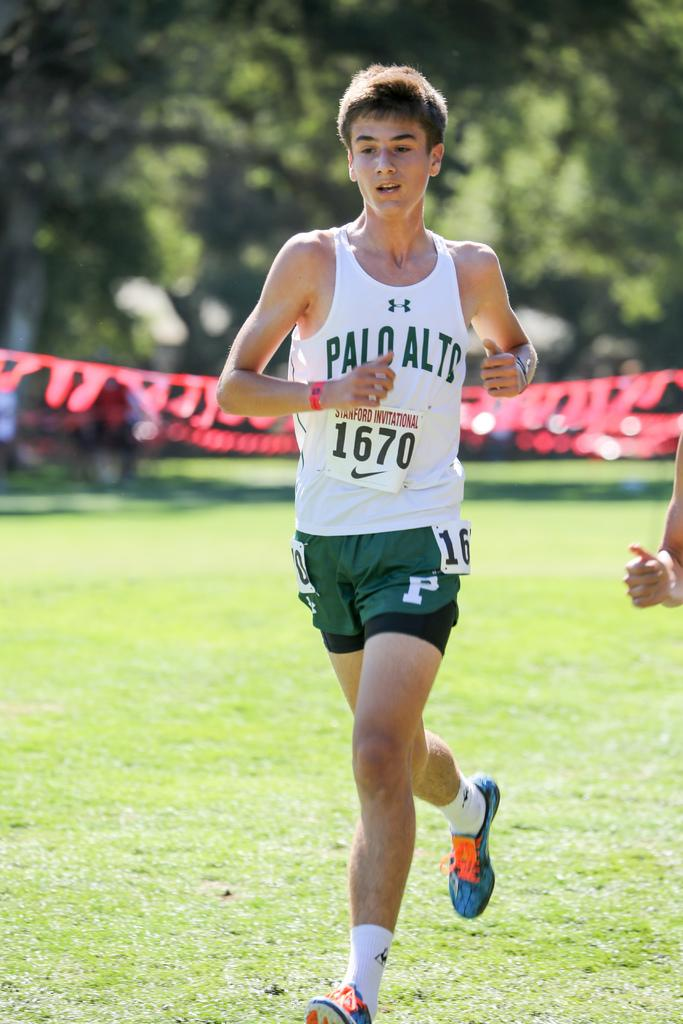<image>
Create a compact narrative representing the image presented. A runner wearing green shorts with the number 16 on them. 